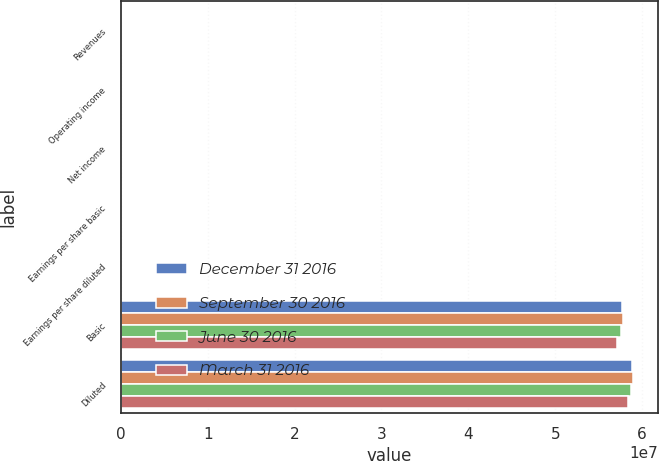<chart> <loc_0><loc_0><loc_500><loc_500><stacked_bar_chart><ecel><fcel>Revenues<fcel>Operating income<fcel>Net income<fcel>Earnings per share basic<fcel>Earnings per share diluted<fcel>Basic<fcel>Diluted<nl><fcel>December 31 2016<fcel>87810<fcel>12681<fcel>8633<fcel>0.15<fcel>0.15<fcel>5.76525e+07<fcel>5.8883e+07<nl><fcel>September 30 2016<fcel>77325<fcel>582<fcel>6198<fcel>0.11<fcel>0.1<fcel>5.78197e+07<fcel>5.89073e+07<nl><fcel>June 30 2016<fcel>73880<fcel>16004<fcel>10421<fcel>0.18<fcel>0.18<fcel>5.75916e+07<fcel>5.86972e+07<nl><fcel>March 31 2016<fcel>90126<fcel>28704<fcel>18588<fcel>0.32<fcel>0.31<fcel>5.71329e+07<fcel>5.8362e+07<nl></chart> 